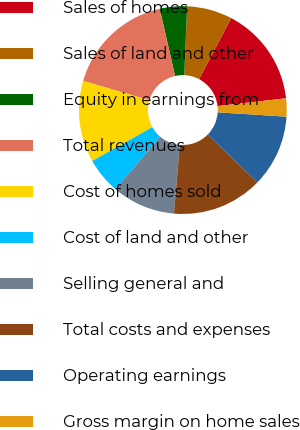Convert chart to OTSL. <chart><loc_0><loc_0><loc_500><loc_500><pie_chart><fcel>Sales of homes<fcel>Sales of land and other<fcel>Equity in earnings from<fcel>Total revenues<fcel>Cost of homes sold<fcel>Cost of land and other<fcel>Selling general and<fcel>Total costs and expenses<fcel>Operating earnings<fcel>Gross margin on home sales<nl><fcel>15.49%<fcel>7.04%<fcel>4.23%<fcel>16.9%<fcel>12.68%<fcel>5.63%<fcel>9.86%<fcel>14.08%<fcel>11.27%<fcel>2.82%<nl></chart> 